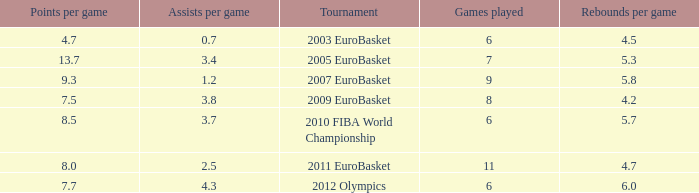How many games played have 4.7 as points per game? 6.0. 